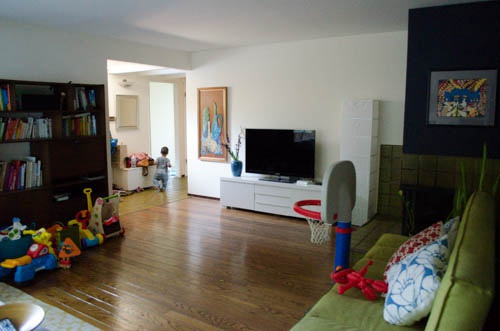Describe the objects in this image and their specific colors. I can see couch in gray, black, darkgreen, olive, and maroon tones, book in gray, black, and ivory tones, tv in gray, black, and darkblue tones, people in gray, darkgray, and black tones, and potted plant in gray, darkgray, navy, and lightgray tones in this image. 